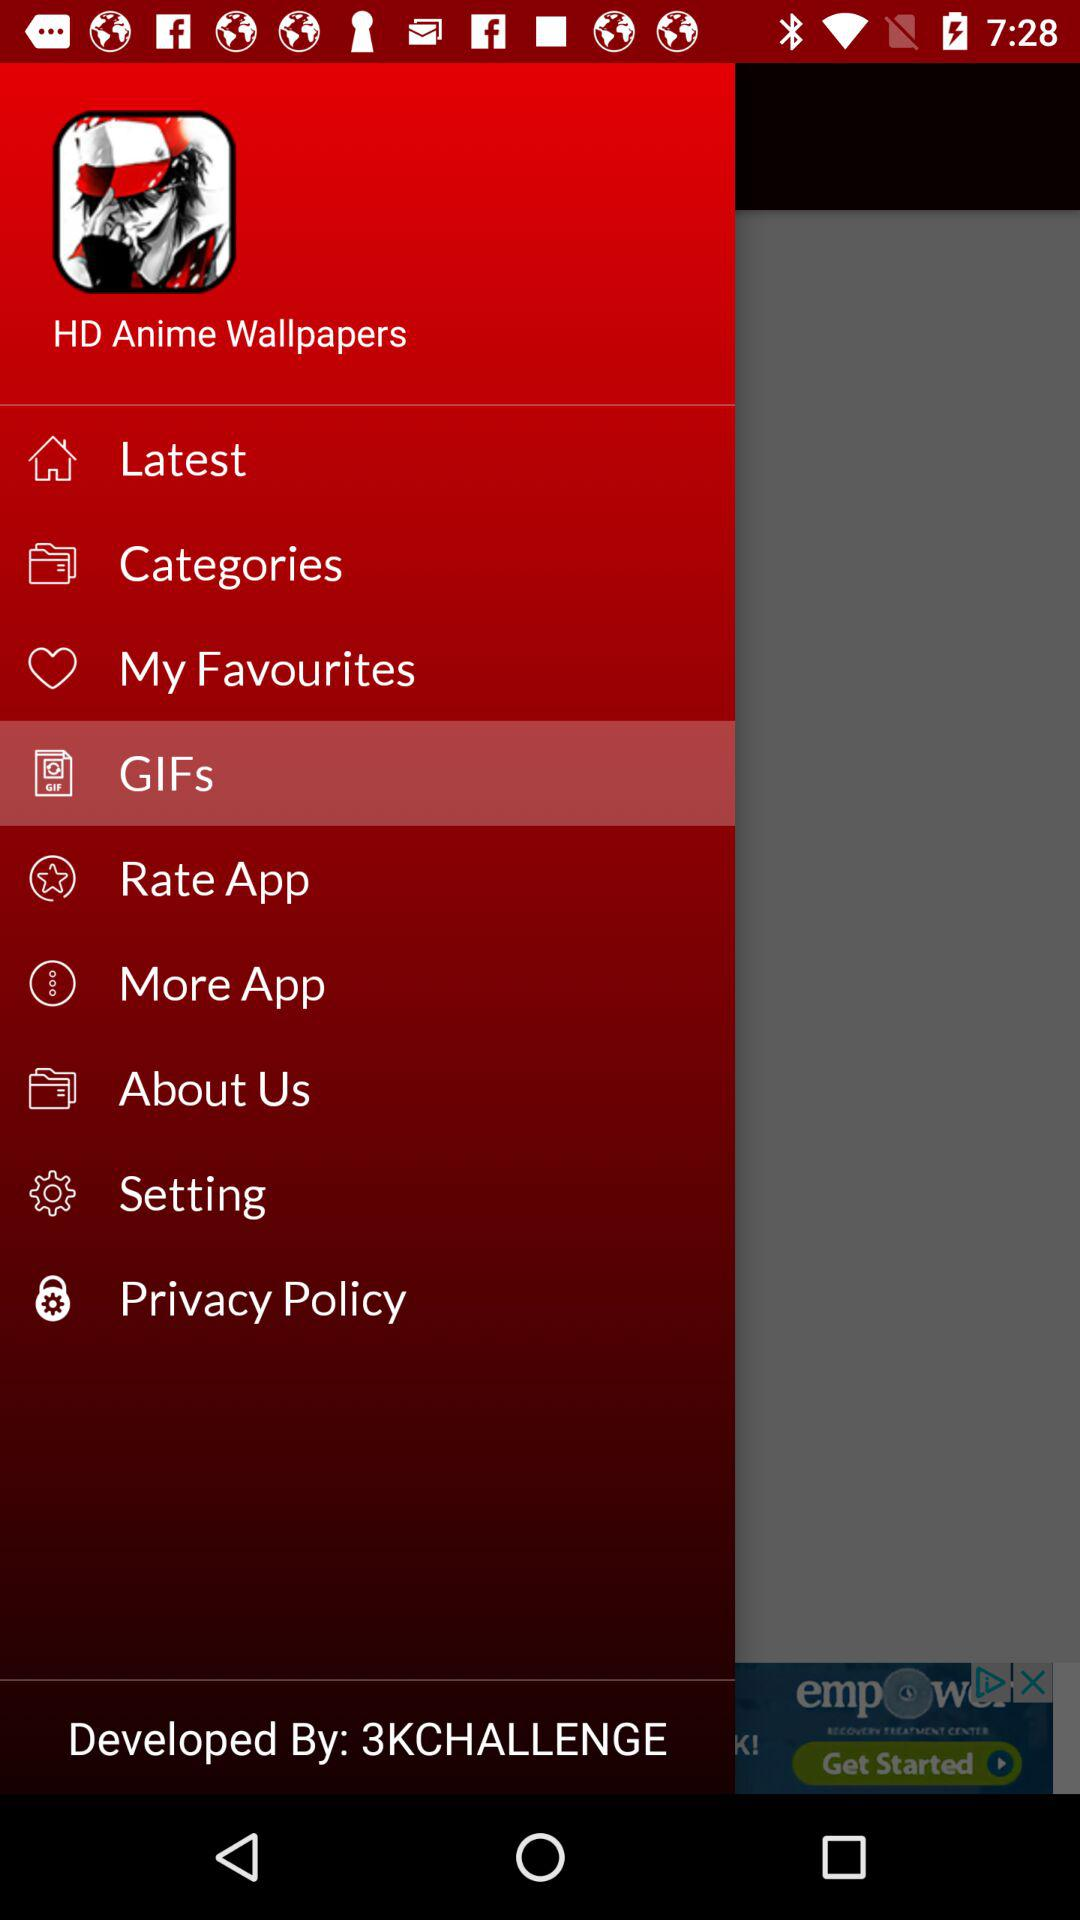What is the application name? The application name is "HD Anime Wallpapers". 